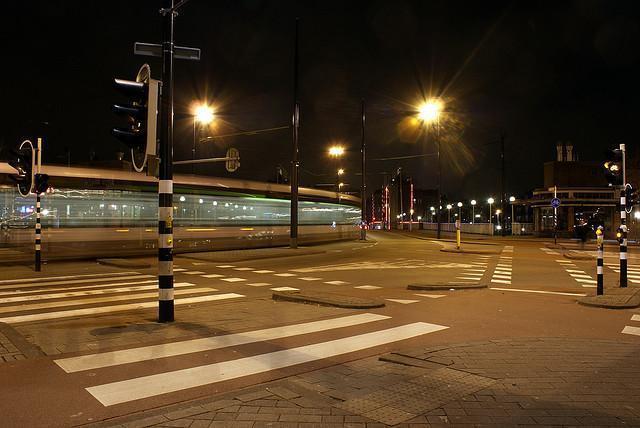What time of day is shown here?
Choose the right answer and clarify with the format: 'Answer: answer
Rationale: rationale.'
Options: Late night, 9 am, noon, 5 pm. Answer: late night.
Rationale: The time of day is late at night. 